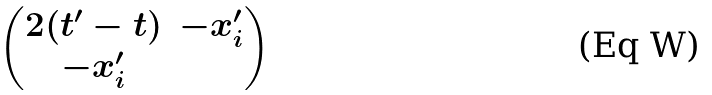<formula> <loc_0><loc_0><loc_500><loc_500>\begin{pmatrix} 2 ( t ^ { \prime } - t ) & - x _ { i } ^ { \prime } \\ - x _ { i } ^ { \prime } & \end{pmatrix}</formula> 